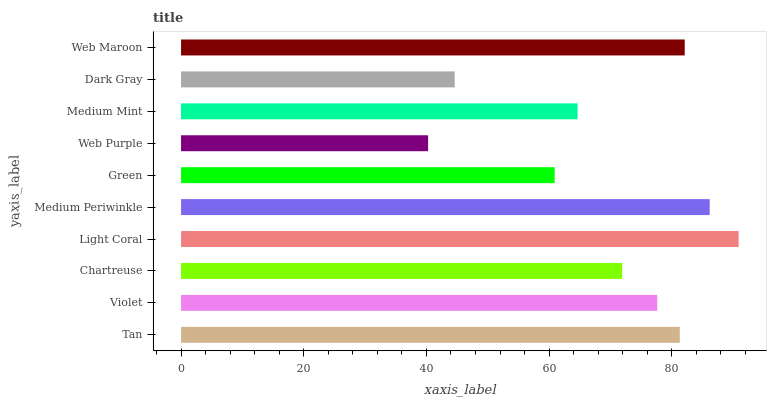Is Web Purple the minimum?
Answer yes or no. Yes. Is Light Coral the maximum?
Answer yes or no. Yes. Is Violet the minimum?
Answer yes or no. No. Is Violet the maximum?
Answer yes or no. No. Is Tan greater than Violet?
Answer yes or no. Yes. Is Violet less than Tan?
Answer yes or no. Yes. Is Violet greater than Tan?
Answer yes or no. No. Is Tan less than Violet?
Answer yes or no. No. Is Violet the high median?
Answer yes or no. Yes. Is Chartreuse the low median?
Answer yes or no. Yes. Is Web Purple the high median?
Answer yes or no. No. Is Medium Mint the low median?
Answer yes or no. No. 